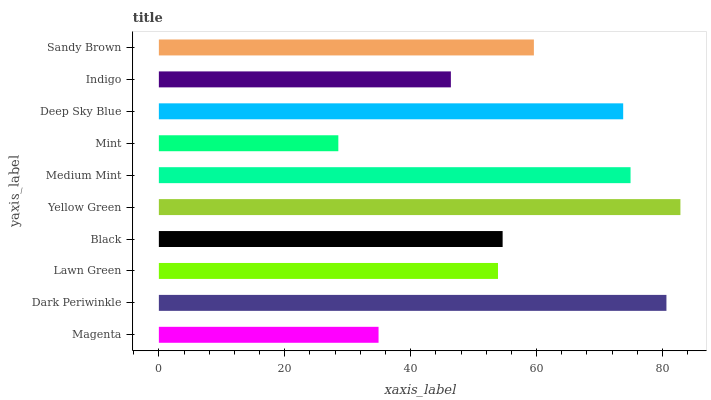Is Mint the minimum?
Answer yes or no. Yes. Is Yellow Green the maximum?
Answer yes or no. Yes. Is Dark Periwinkle the minimum?
Answer yes or no. No. Is Dark Periwinkle the maximum?
Answer yes or no. No. Is Dark Periwinkle greater than Magenta?
Answer yes or no. Yes. Is Magenta less than Dark Periwinkle?
Answer yes or no. Yes. Is Magenta greater than Dark Periwinkle?
Answer yes or no. No. Is Dark Periwinkle less than Magenta?
Answer yes or no. No. Is Sandy Brown the high median?
Answer yes or no. Yes. Is Black the low median?
Answer yes or no. Yes. Is Magenta the high median?
Answer yes or no. No. Is Medium Mint the low median?
Answer yes or no. No. 